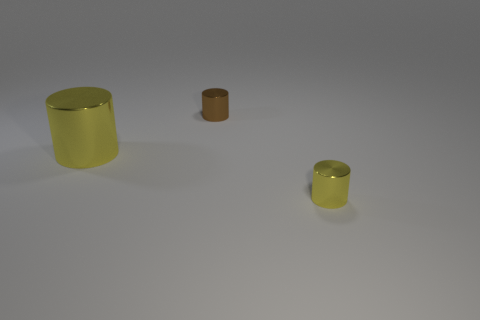How many spheres are either small brown things or yellow things?
Offer a terse response. 0. Is the large metal object the same shape as the small brown metallic object?
Make the answer very short. Yes. What is the size of the yellow cylinder that is right of the brown cylinder?
Provide a succinct answer. Small. Is there a big metal cube of the same color as the big metal cylinder?
Offer a terse response. No. There is a yellow cylinder on the left side of the brown metal object; is it the same size as the brown cylinder?
Your answer should be very brief. No. The big shiny cylinder has what color?
Provide a succinct answer. Yellow. The small object that is in front of the large cylinder that is to the left of the small brown shiny cylinder is what color?
Your answer should be compact. Yellow. Are there any other large things that have the same material as the brown object?
Provide a short and direct response. Yes. There is a tiny cylinder that is left of the tiny metallic object that is in front of the large thing; what is its material?
Offer a very short reply. Metal. How many small brown metallic objects are the same shape as the small yellow object?
Provide a short and direct response. 1. 